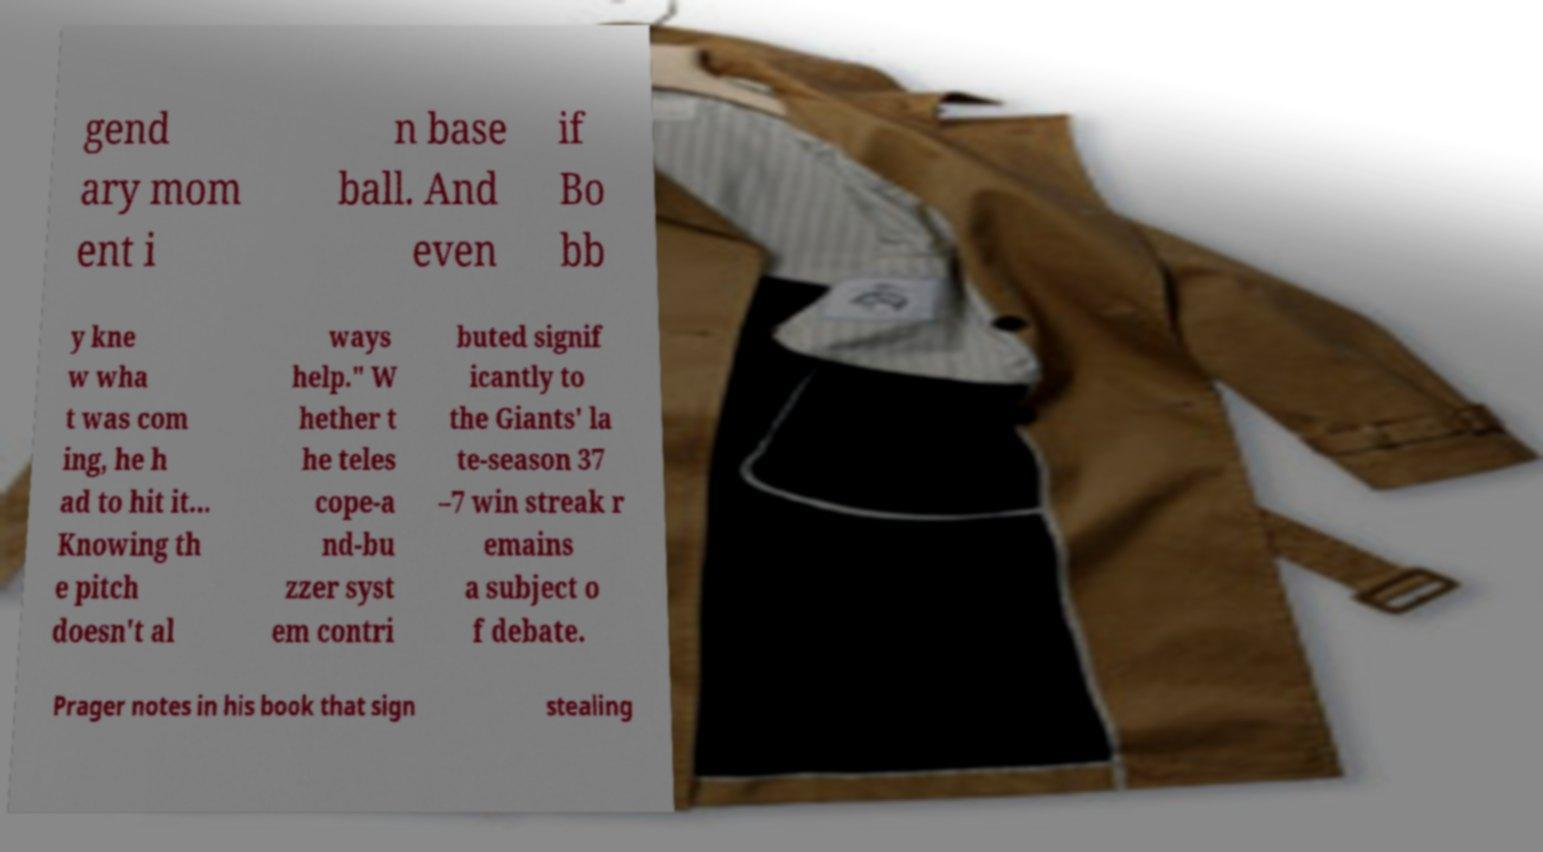Can you read and provide the text displayed in the image?This photo seems to have some interesting text. Can you extract and type it out for me? gend ary mom ent i n base ball. And even if Bo bb y kne w wha t was com ing, he h ad to hit it... Knowing th e pitch doesn't al ways help." W hether t he teles cope-a nd-bu zzer syst em contri buted signif icantly to the Giants' la te-season 37 –7 win streak r emains a subject o f debate. Prager notes in his book that sign stealing 